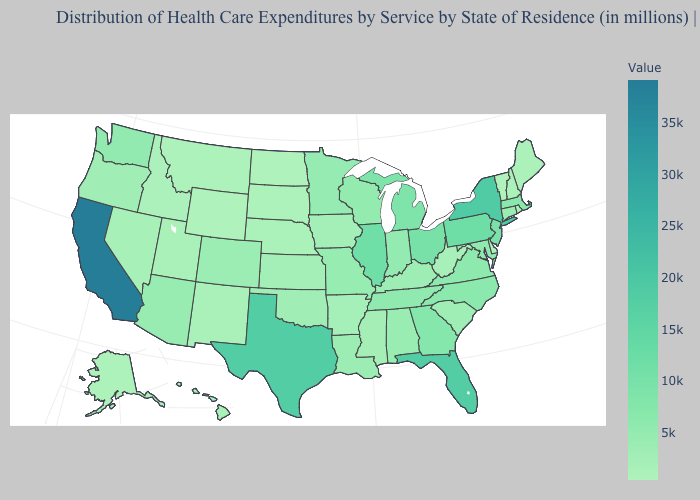Does the map have missing data?
Short answer required. No. Among the states that border Virginia , which have the lowest value?
Concise answer only. West Virginia. Among the states that border Texas , which have the lowest value?
Quick response, please. New Mexico. Does Indiana have the lowest value in the MidWest?
Quick response, please. No. Does Wyoming have the lowest value in the USA?
Quick response, please. Yes. Among the states that border Utah , which have the lowest value?
Short answer required. Wyoming. 